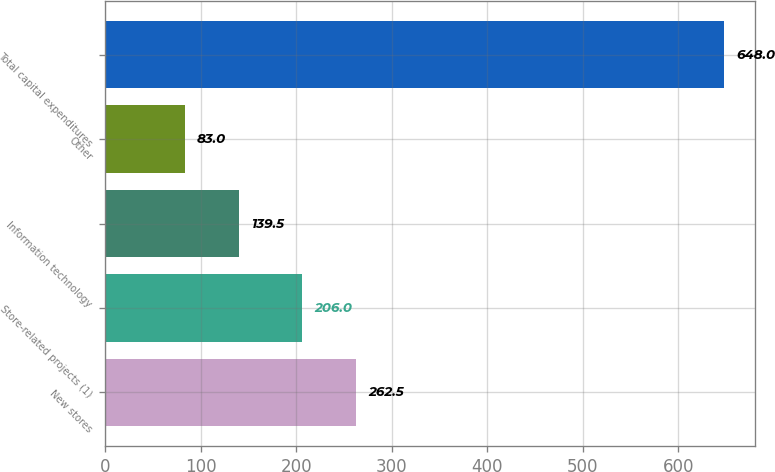Convert chart to OTSL. <chart><loc_0><loc_0><loc_500><loc_500><bar_chart><fcel>New stores<fcel>Store-related projects (1)<fcel>Information technology<fcel>Other<fcel>Total capital expenditures<nl><fcel>262.5<fcel>206<fcel>139.5<fcel>83<fcel>648<nl></chart> 